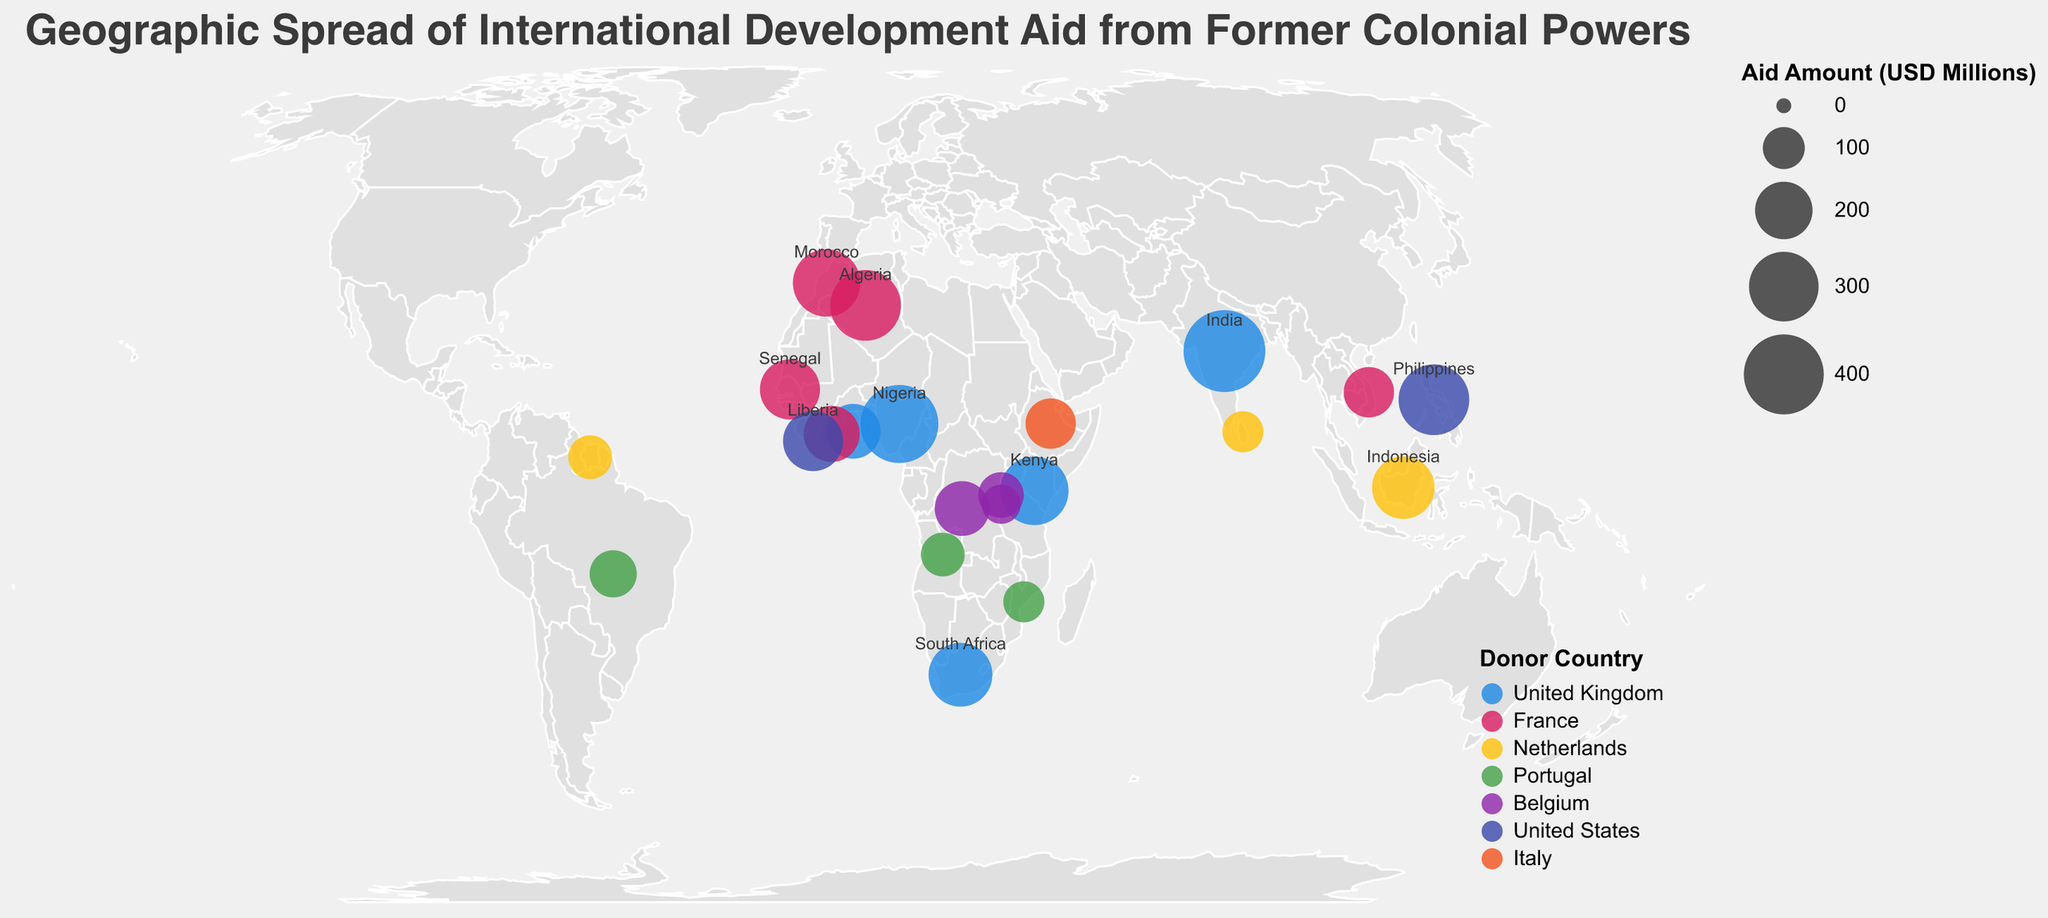Which country received the highest amount of aid from the United Kingdom? The chart shows the aid distribution from various former colonial powers, with different countries marked by circles. Each circle's size correlates to the aid amount. The largest circle representing aid from the United Kingdom is for India.
Answer: India Which donor country provided the most aid to Nigeria? By observing the color of the circle that represents Nigeria, the color corresponds to the United Kingdom, which is confirmed in the legend.
Answer: United Kingdom What is the total aid amount received by countries from France? To find the total, sum the aid amounts for all countries receiving aid from France: Algeria (310), Morocco (280), Senegal (220), Côte d'Ivoire (190), and Vietnam (150). Thus, 310 + 280 + 220 + 190 + 150 = 1150 million USD.
Answer: 1150 million USD Which country focuses its aid primarily on Governance? The tooltip information shows that Liberia's primary focus of aid from the United States is Governance.
Answer: Liberia Comparing aid from the Netherlands, which country received the least amount of aid and what's the amount? By comparing the sizes of the circles representing countries receiving aid from the Netherlands, Suriname received the smallest aid amount of 110 million USD.
Answer: Suriname, 110 million USD Which donor country has the widest geographical spread of aid recipients? By examining the plot, the United Kingdom provides aid to the most geographically diverse set, including countries in Africa, Asia, and Europe.
Answer: United Kingdom How much more aid did Indonesia receive from the Netherlands compared to Sri Lanka? Indonesia received 240 million USD and Sri Lanka received 95 million USD. The difference is 240 - 95 = 145 million USD.
Answer: 145 million USD What is the primary focus of aid for Ethiopia from Italy? The tooltip for Ethiopia indicates that the primary focus of aid from Italy is Food Security.
Answer: Food Security 